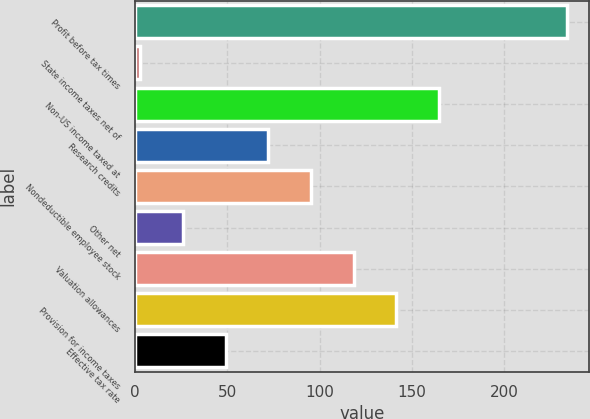Convert chart to OTSL. <chart><loc_0><loc_0><loc_500><loc_500><bar_chart><fcel>Profit before tax times<fcel>State income taxes net of<fcel>Non-US income taxed at<fcel>Research credits<fcel>Nondeductible employee stock<fcel>Other net<fcel>Valuation allowances<fcel>Provision for income taxes<fcel>Effective tax rate<nl><fcel>234<fcel>3<fcel>164.7<fcel>72.3<fcel>95.4<fcel>26.1<fcel>118.5<fcel>141.6<fcel>49.2<nl></chart> 